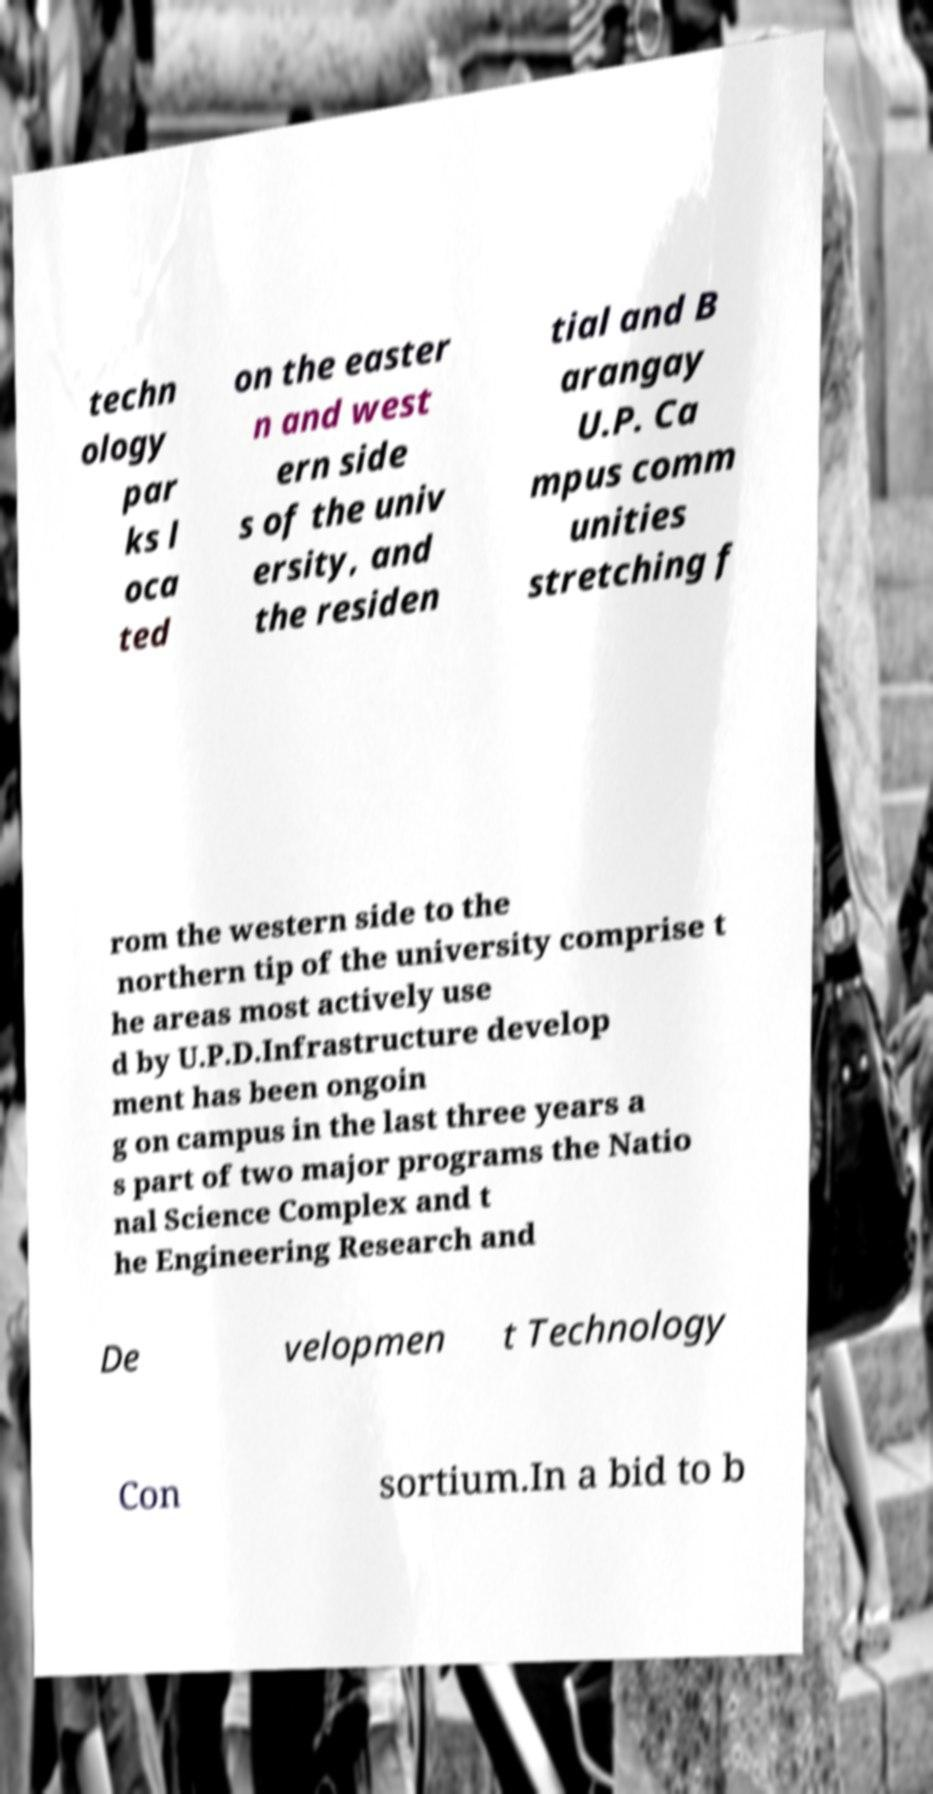Can you read and provide the text displayed in the image?This photo seems to have some interesting text. Can you extract and type it out for me? techn ology par ks l oca ted on the easter n and west ern side s of the univ ersity, and the residen tial and B arangay U.P. Ca mpus comm unities stretching f rom the western side to the northern tip of the university comprise t he areas most actively use d by U.P.D.Infrastructure develop ment has been ongoin g on campus in the last three years a s part of two major programs the Natio nal Science Complex and t he Engineering Research and De velopmen t Technology Con sortium.In a bid to b 